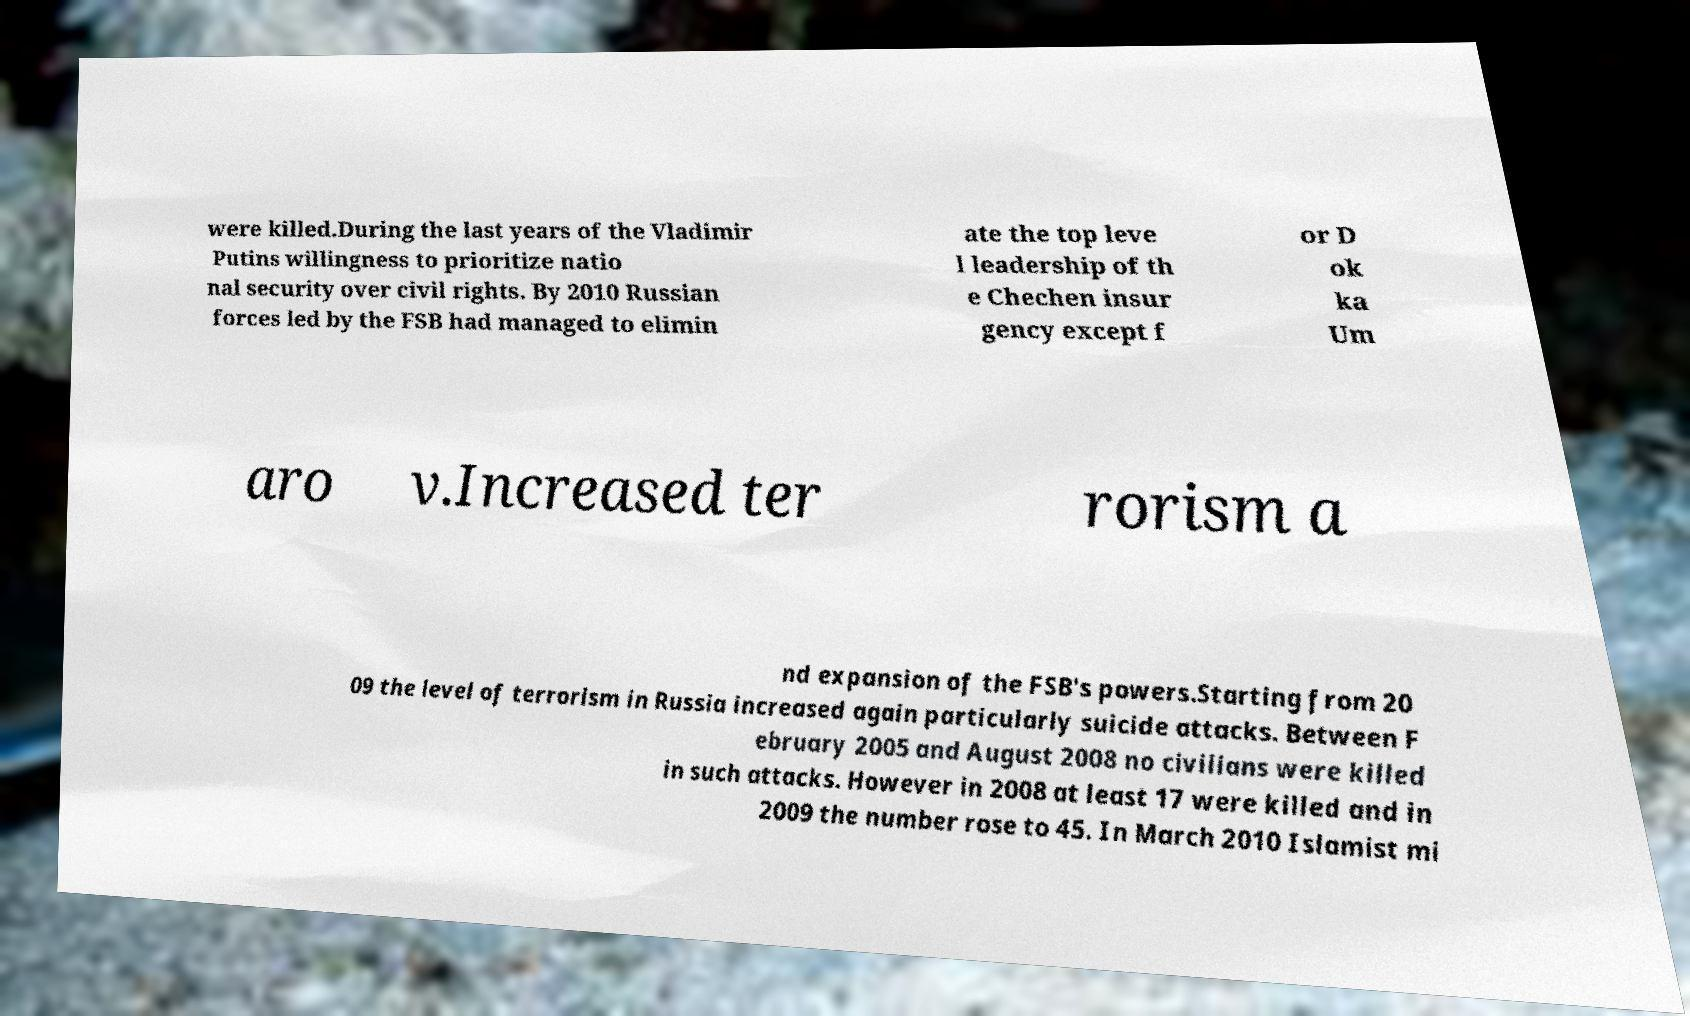Can you read and provide the text displayed in the image?This photo seems to have some interesting text. Can you extract and type it out for me? were killed.During the last years of the Vladimir Putins willingness to prioritize natio nal security over civil rights. By 2010 Russian forces led by the FSB had managed to elimin ate the top leve l leadership of th e Chechen insur gency except f or D ok ka Um aro v.Increased ter rorism a nd expansion of the FSB's powers.Starting from 20 09 the level of terrorism in Russia increased again particularly suicide attacks. Between F ebruary 2005 and August 2008 no civilians were killed in such attacks. However in 2008 at least 17 were killed and in 2009 the number rose to 45. In March 2010 Islamist mi 